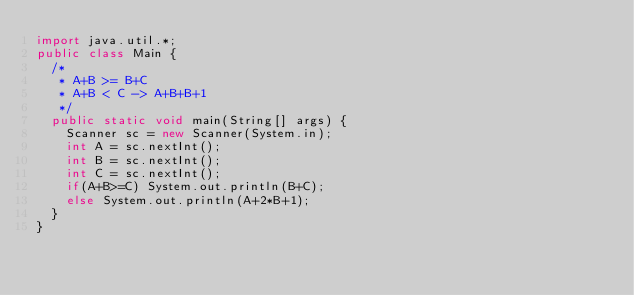<code> <loc_0><loc_0><loc_500><loc_500><_Java_>import java.util.*;
public class Main {
	/*
	 * A+B >= B+C
	 * A+B < C -> A+B+B+1
	 */
	public static void main(String[] args) {
		Scanner sc = new Scanner(System.in);
		int A = sc.nextInt();
		int B = sc.nextInt();
		int C = sc.nextInt();
		if(A+B>=C) System.out.println(B+C);
		else System.out.println(A+2*B+1);
	}
}
</code> 